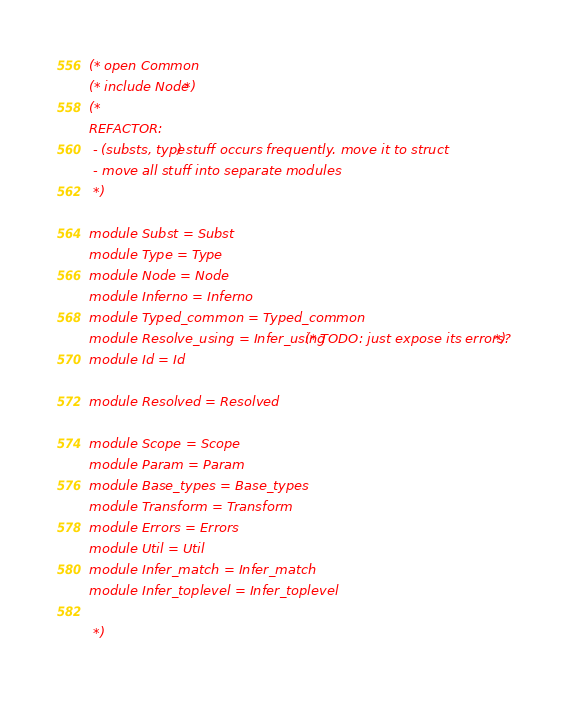<code> <loc_0><loc_0><loc_500><loc_500><_OCaml_>(* open Common
(* include Node *)
(*
REFACTOR:
 - (substs, type) stuff occurs frequently. move it to struct
 - move all stuff into separate modules
 *)

module Subst = Subst
module Type = Type 
module Node = Node
module Inferno = Inferno
module Typed_common = Typed_common
module Resolve_using = Infer_using (* TODO: just expose its errors? *)
module Id = Id

module Resolved = Resolved

module Scope = Scope
module Param = Param
module Base_types = Base_types
module Transform = Transform
module Errors = Errors
module Util = Util
module Infer_match = Infer_match
module Infer_toplevel = Infer_toplevel

 *)
</code> 